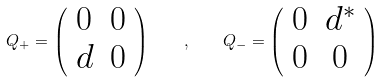Convert formula to latex. <formula><loc_0><loc_0><loc_500><loc_500>Q _ { + } = \left ( \begin{array} { c c } 0 & 0 \\ d & 0 \end{array} \right ) \quad , \quad Q _ { - } = \left ( \begin{array} { c c } 0 & d ^ { * } \\ 0 & 0 \end{array} \right )</formula> 